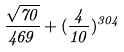Convert formula to latex. <formula><loc_0><loc_0><loc_500><loc_500>\frac { \sqrt { 7 0 } } { 4 6 9 } + ( \frac { 4 } { 1 0 } ) ^ { 3 0 4 }</formula> 